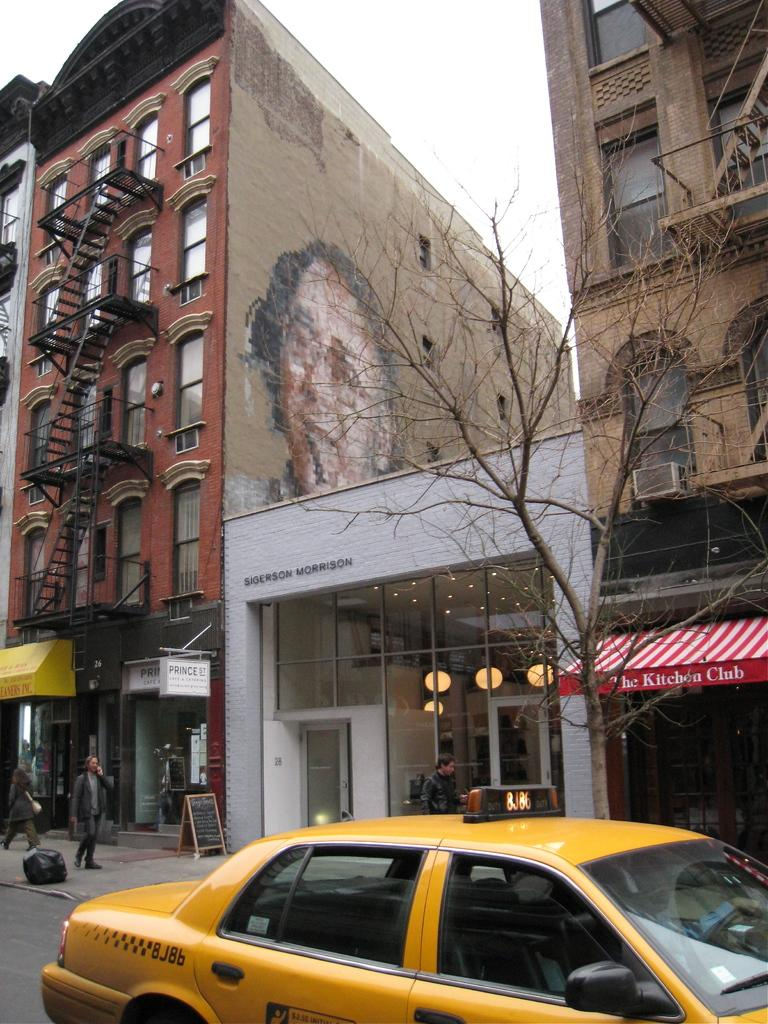Provide a one-sentence caption for the provided image. A mural of a man's face is painted on the side of a building above a Sigerson Morrison store. 